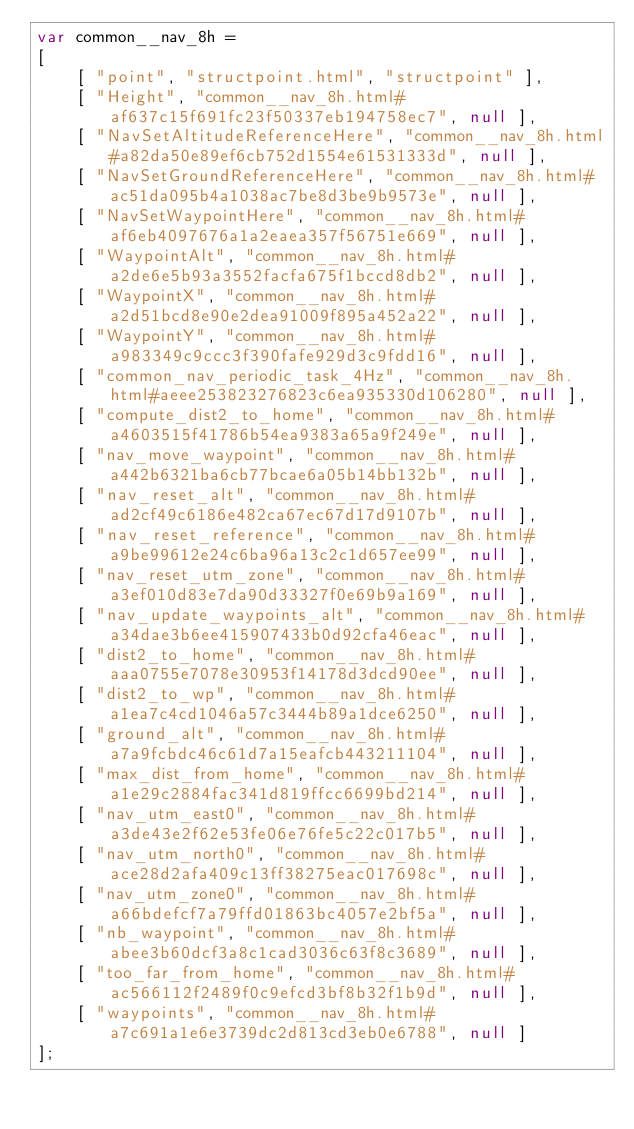Convert code to text. <code><loc_0><loc_0><loc_500><loc_500><_JavaScript_>var common__nav_8h =
[
    [ "point", "structpoint.html", "structpoint" ],
    [ "Height", "common__nav_8h.html#af637c15f691fc23f50337eb194758ec7", null ],
    [ "NavSetAltitudeReferenceHere", "common__nav_8h.html#a82da50e89ef6cb752d1554e61531333d", null ],
    [ "NavSetGroundReferenceHere", "common__nav_8h.html#ac51da095b4a1038ac7be8d3be9b9573e", null ],
    [ "NavSetWaypointHere", "common__nav_8h.html#af6eb4097676a1a2eaea357f56751e669", null ],
    [ "WaypointAlt", "common__nav_8h.html#a2de6e5b93a3552facfa675f1bccd8db2", null ],
    [ "WaypointX", "common__nav_8h.html#a2d51bcd8e90e2dea91009f895a452a22", null ],
    [ "WaypointY", "common__nav_8h.html#a983349c9ccc3f390fafe929d3c9fdd16", null ],
    [ "common_nav_periodic_task_4Hz", "common__nav_8h.html#aeee253823276823c6ea935330d106280", null ],
    [ "compute_dist2_to_home", "common__nav_8h.html#a4603515f41786b54ea9383a65a9f249e", null ],
    [ "nav_move_waypoint", "common__nav_8h.html#a442b6321ba6cb77bcae6a05b14bb132b", null ],
    [ "nav_reset_alt", "common__nav_8h.html#ad2cf49c6186e482ca67ec67d17d9107b", null ],
    [ "nav_reset_reference", "common__nav_8h.html#a9be99612e24c6ba96a13c2c1d657ee99", null ],
    [ "nav_reset_utm_zone", "common__nav_8h.html#a3ef010d83e7da90d33327f0e69b9a169", null ],
    [ "nav_update_waypoints_alt", "common__nav_8h.html#a34dae3b6ee415907433b0d92cfa46eac", null ],
    [ "dist2_to_home", "common__nav_8h.html#aaa0755e7078e30953f14178d3dcd90ee", null ],
    [ "dist2_to_wp", "common__nav_8h.html#a1ea7c4cd1046a57c3444b89a1dce6250", null ],
    [ "ground_alt", "common__nav_8h.html#a7a9fcbdc46c61d7a15eafcb443211104", null ],
    [ "max_dist_from_home", "common__nav_8h.html#a1e29c2884fac341d819ffcc6699bd214", null ],
    [ "nav_utm_east0", "common__nav_8h.html#a3de43e2f62e53fe06e76fe5c22c017b5", null ],
    [ "nav_utm_north0", "common__nav_8h.html#ace28d2afa409c13ff38275eac017698c", null ],
    [ "nav_utm_zone0", "common__nav_8h.html#a66bdefcf7a79ffd01863bc4057e2bf5a", null ],
    [ "nb_waypoint", "common__nav_8h.html#abee3b60dcf3a8c1cad3036c63f8c3689", null ],
    [ "too_far_from_home", "common__nav_8h.html#ac566112f2489f0c9efcd3bf8b32f1b9d", null ],
    [ "waypoints", "common__nav_8h.html#a7c691a1e6e3739dc2d813cd3eb0e6788", null ]
];</code> 